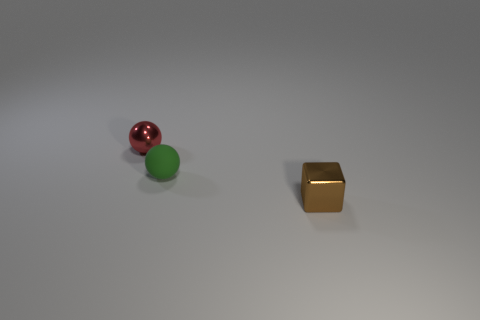Add 2 brown objects. How many objects exist? 5 Subtract all spheres. How many objects are left? 1 Subtract 0 red cylinders. How many objects are left? 3 Subtract all purple matte blocks. Subtract all shiny things. How many objects are left? 1 Add 1 green spheres. How many green spheres are left? 2 Add 2 tiny red spheres. How many tiny red spheres exist? 3 